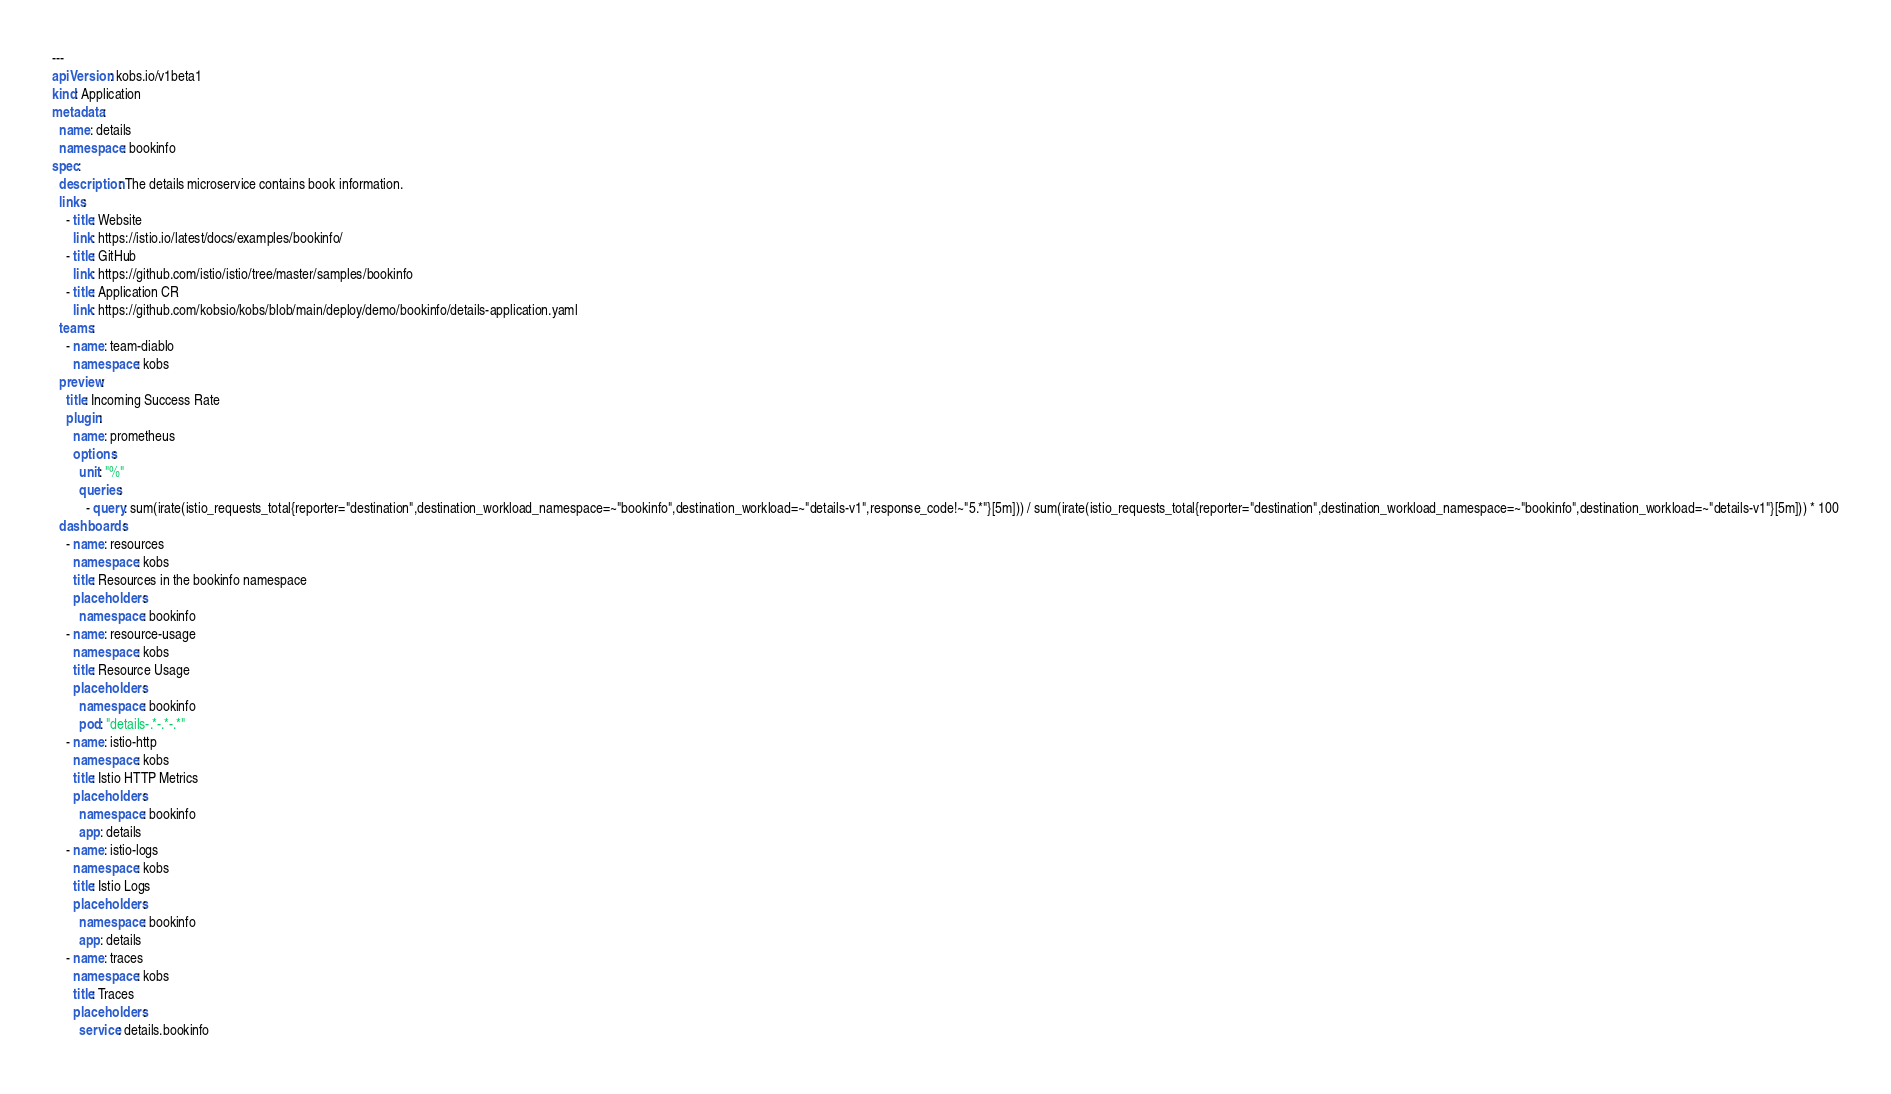Convert code to text. <code><loc_0><loc_0><loc_500><loc_500><_YAML_>---
apiVersion: kobs.io/v1beta1
kind: Application
metadata:
  name: details
  namespace: bookinfo
spec:
  description: The details microservice contains book information.
  links:
    - title: Website
      link: https://istio.io/latest/docs/examples/bookinfo/
    - title: GitHub
      link: https://github.com/istio/istio/tree/master/samples/bookinfo
    - title: Application CR
      link: https://github.com/kobsio/kobs/blob/main/deploy/demo/bookinfo/details-application.yaml
  teams:
    - name: team-diablo
      namespace: kobs
  preview:
    title: Incoming Success Rate
    plugin:
      name: prometheus
      options:
        unit: "%"
        queries:
          - query: sum(irate(istio_requests_total{reporter="destination",destination_workload_namespace=~"bookinfo",destination_workload=~"details-v1",response_code!~"5.*"}[5m])) / sum(irate(istio_requests_total{reporter="destination",destination_workload_namespace=~"bookinfo",destination_workload=~"details-v1"}[5m])) * 100
  dashboards:
    - name: resources
      namespace: kobs
      title: Resources in the bookinfo namespace
      placeholders:
        namespace: bookinfo
    - name: resource-usage
      namespace: kobs
      title: Resource Usage
      placeholders:
        namespace: bookinfo
        pod: "details-.*-.*-.*"
    - name: istio-http
      namespace: kobs
      title: Istio HTTP Metrics
      placeholders:
        namespace: bookinfo
        app: details
    - name: istio-logs
      namespace: kobs
      title: Istio Logs
      placeholders:
        namespace: bookinfo
        app: details
    - name: traces
      namespace: kobs
      title: Traces
      placeholders:
        service: details.bookinfo
</code> 